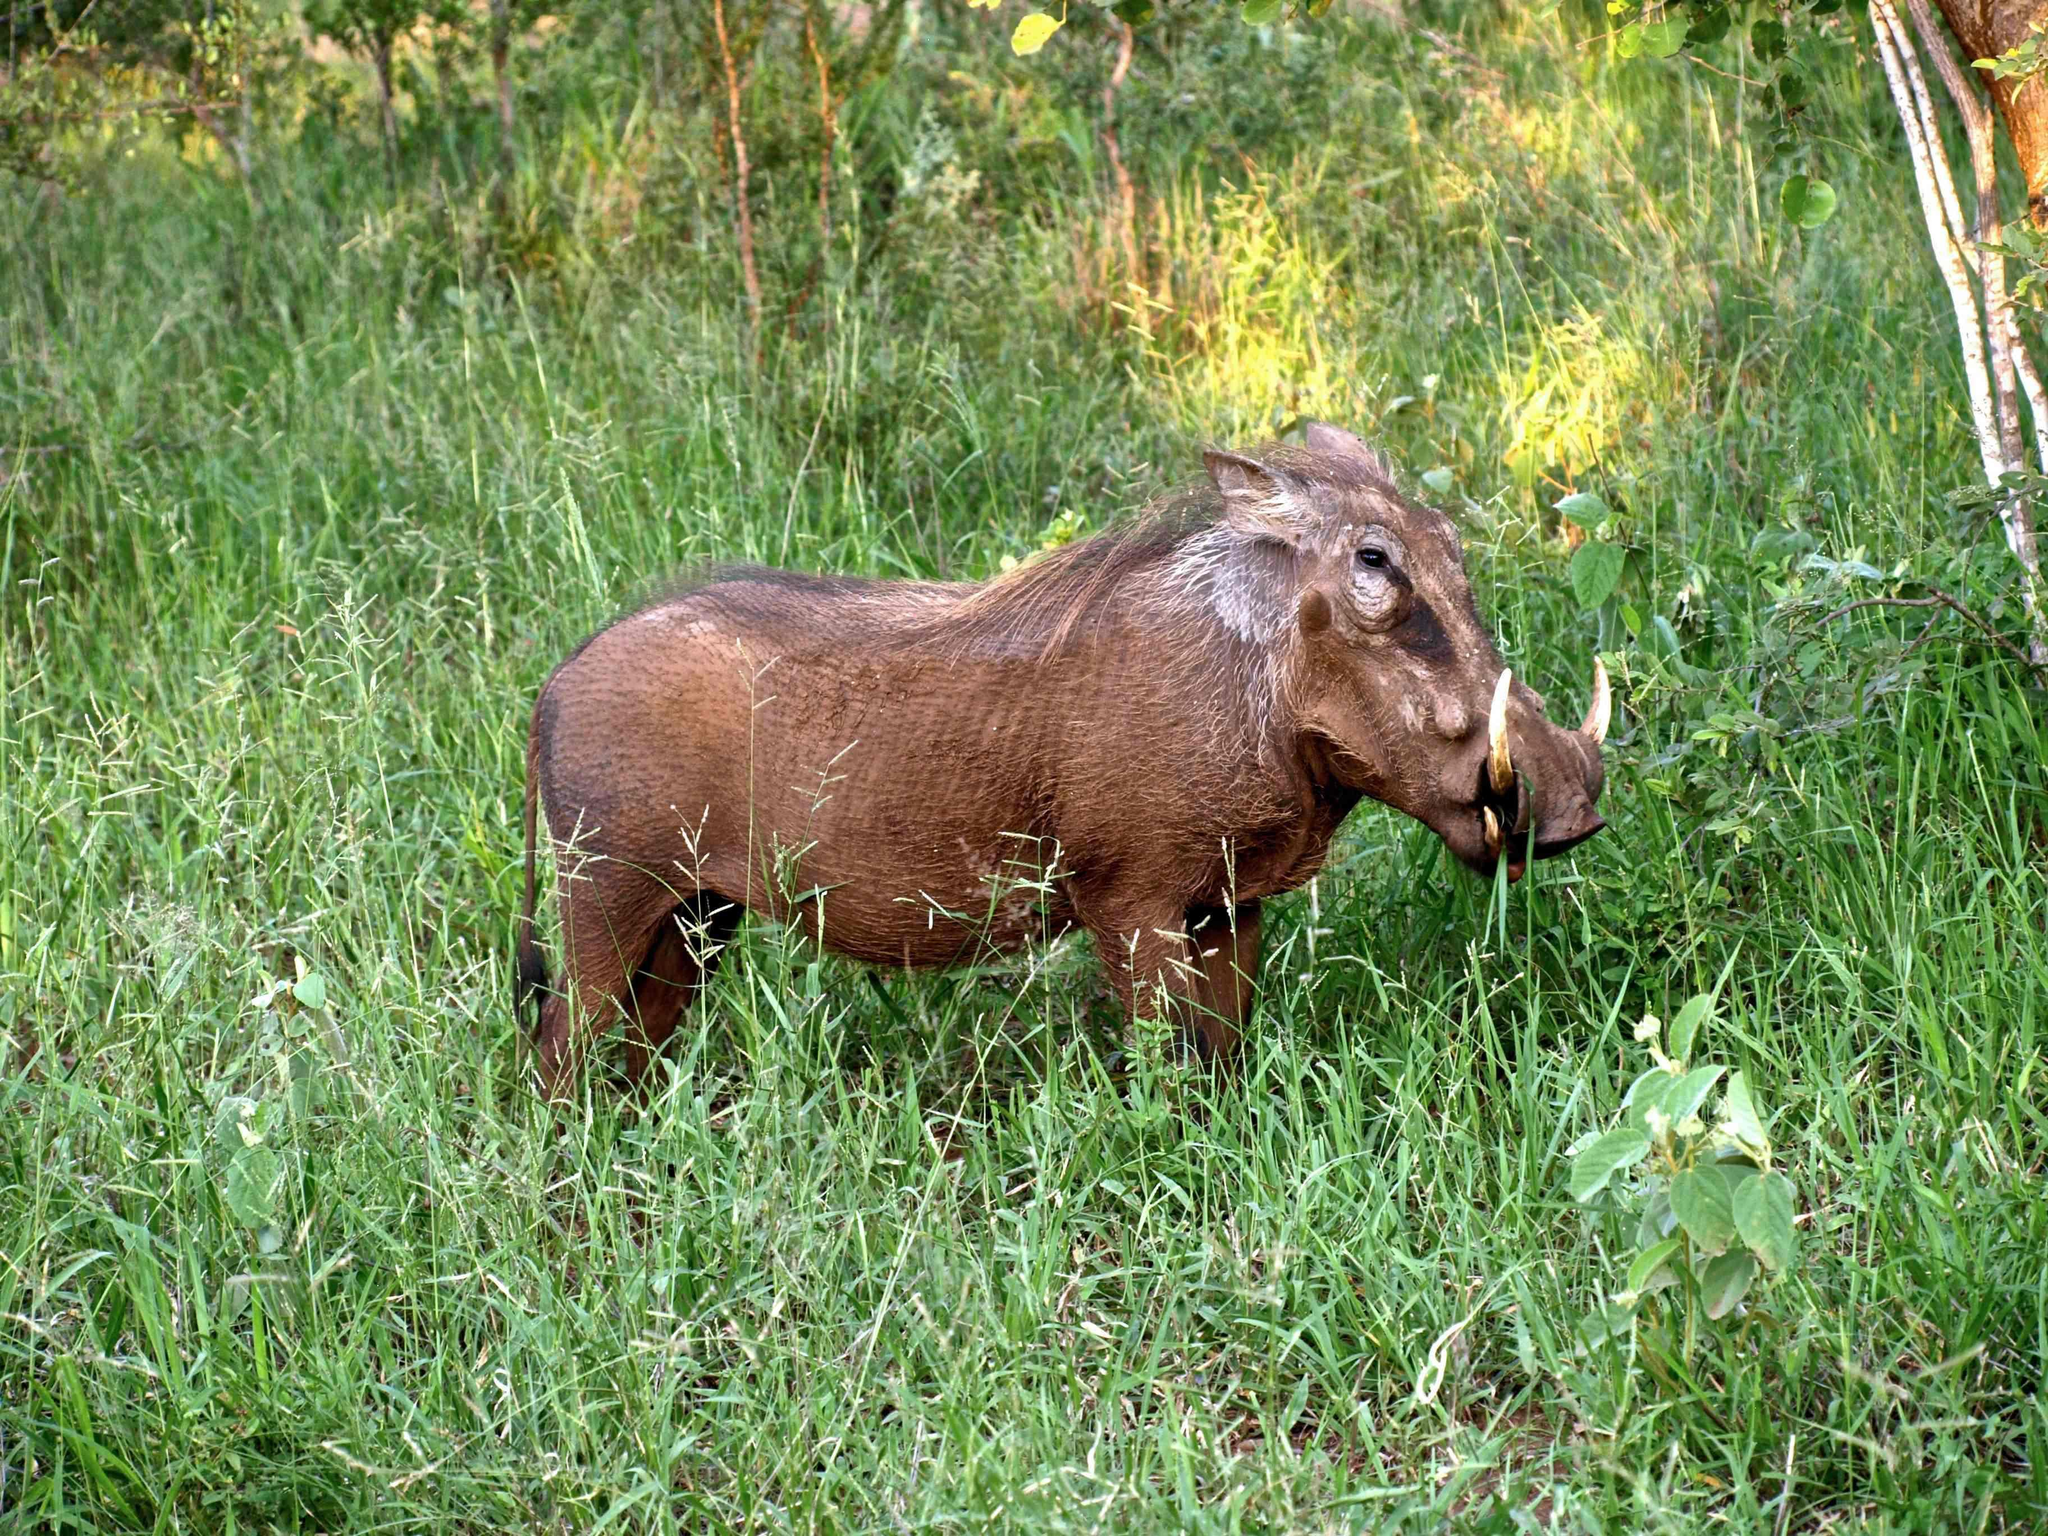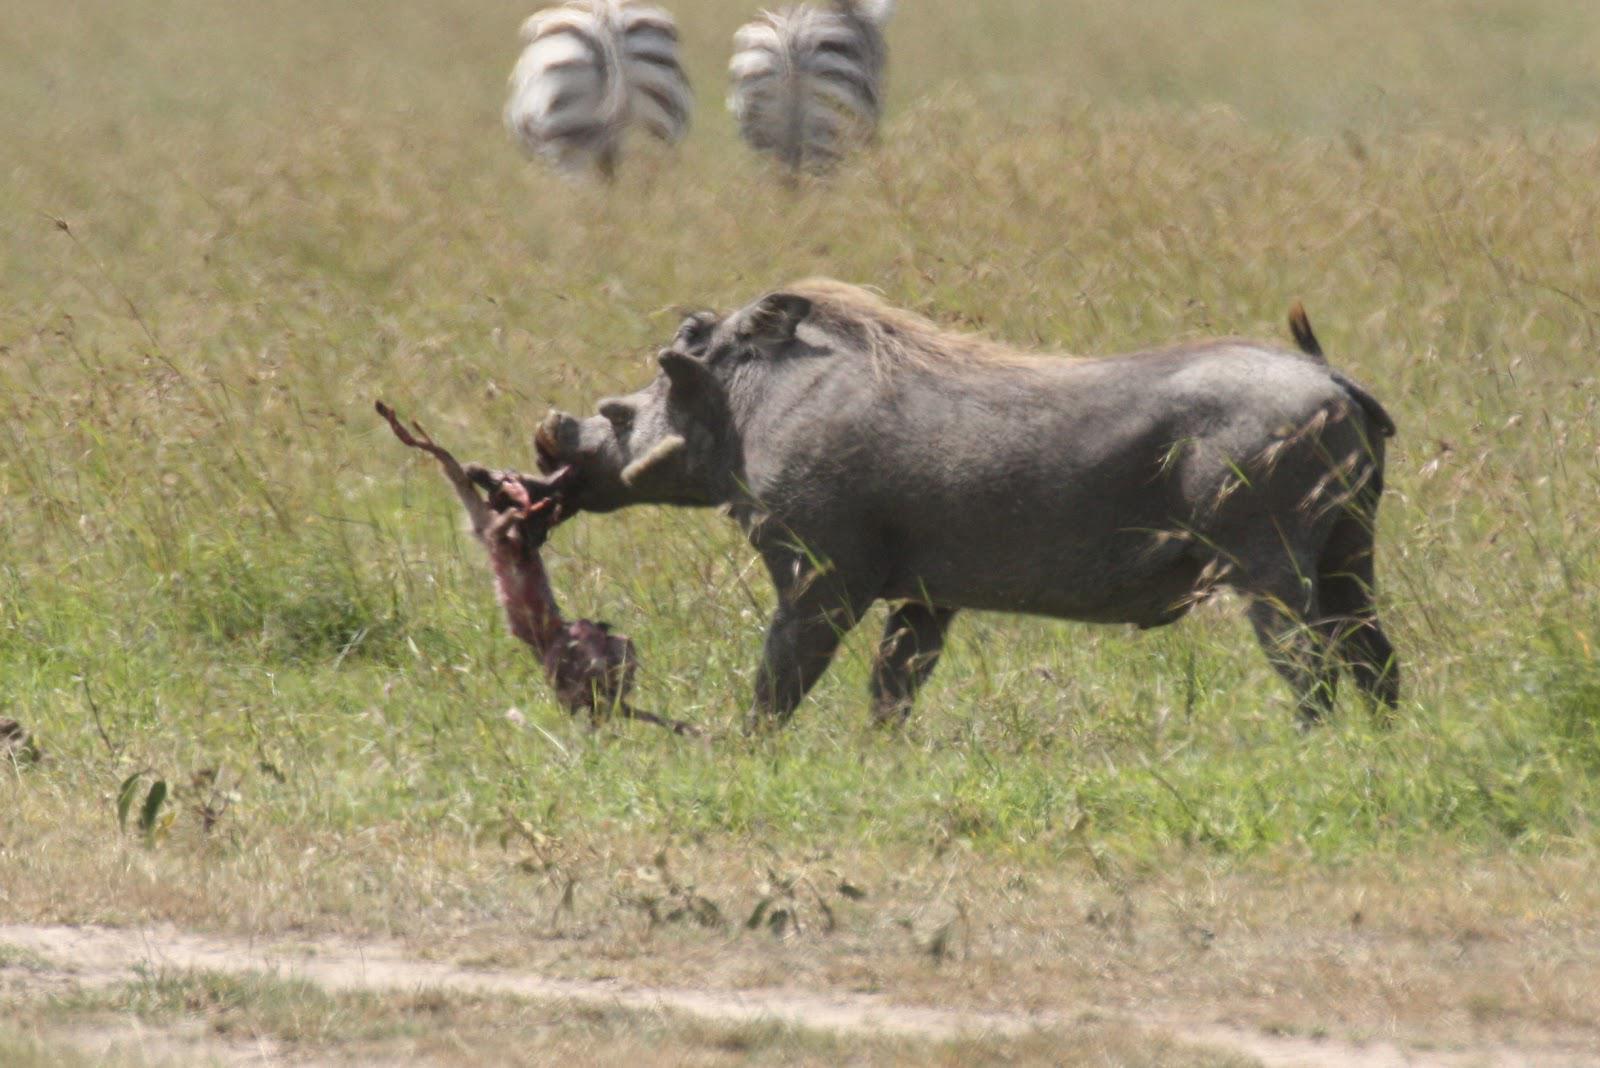The first image is the image on the left, the second image is the image on the right. Examine the images to the left and right. Is the description "All of the wild boars are alive and at least one other type of animal is also alive." accurate? Answer yes or no. Yes. The first image is the image on the left, the second image is the image on the right. Evaluate the accuracy of this statement regarding the images: "There are at least 4 animals.". Is it true? Answer yes or no. Yes. 